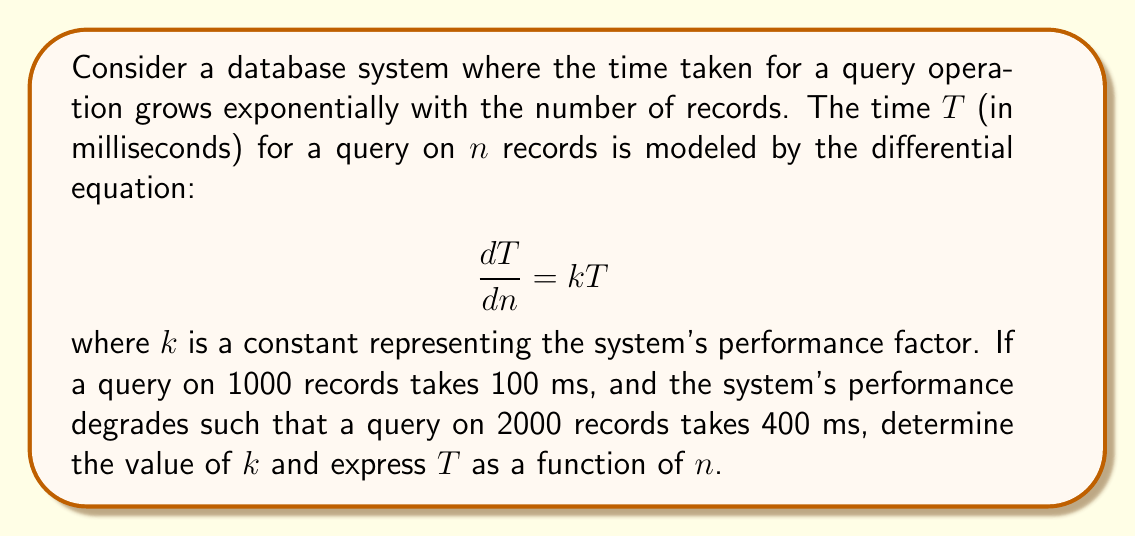Give your solution to this math problem. 1) The given differential equation is:

   $$\frac{dT}{dn} = kT$$

2) This is a separable equation. Rearranging:

   $$\frac{dT}{T} = k\,dn$$

3) Integrating both sides:

   $$\int \frac{dT}{T} = \int k\,dn$$
   $$\ln|T| = kn + C$$

4) Solving for T:

   $$T = Ce^{kn}$$

   where C is a constant of integration.

5) We're given two data points: 
   - When $n = 1000$, $T = 100$
   - When $n = 2000$, $T = 400$

6) Using the first data point:

   $$100 = Ce^{1000k}$$

7) Using the second data point:

   $$400 = Ce^{2000k}$$

8) Dividing these equations:

   $$\frac{400}{100} = \frac{Ce^{2000k}}{Ce^{1000k}} = e^{1000k}$$

9) Simplifying:

   $$4 = e^{1000k}$$
   $$\ln(4) = 1000k$$
   $$k = \frac{\ln(4)}{1000} \approx 0.001386$$

10) To find C, we can use either data point. Using $n = 1000$, $T = 100$:

    $$100 = Ce^{1000 \cdot 0.001386}$$
    $$100 = Ce^{1.386}$$
    $$C = \frac{100}{e^{1.386}} \approx 25$$

11) Therefore, the function $T(n)$ is:

    $$T(n) = 25e^{0.001386n}$$
Answer: $k \approx 0.001386$, $T(n) = 25e^{0.001386n}$ 